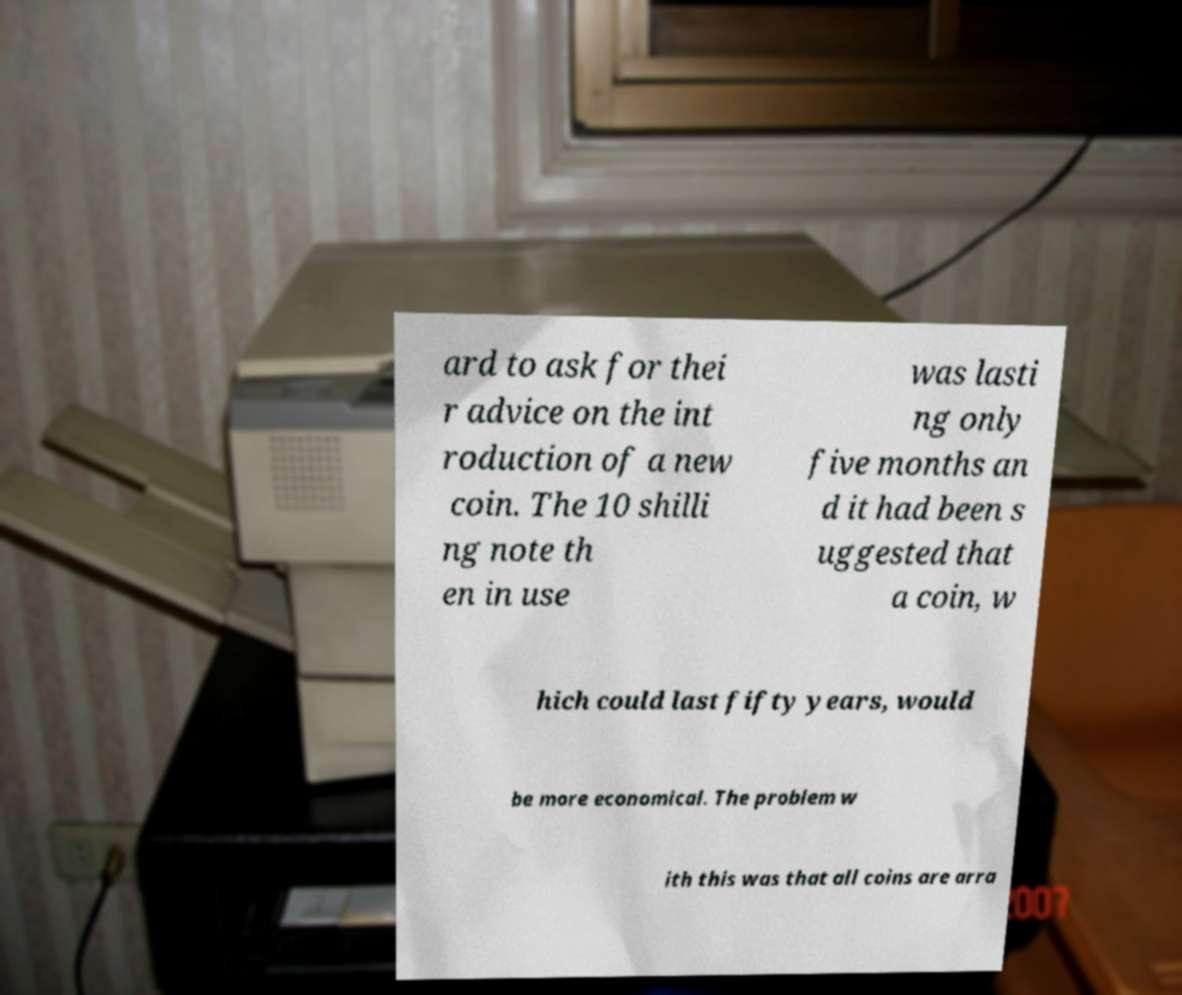There's text embedded in this image that I need extracted. Can you transcribe it verbatim? ard to ask for thei r advice on the int roduction of a new coin. The 10 shilli ng note th en in use was lasti ng only five months an d it had been s uggested that a coin, w hich could last fifty years, would be more economical. The problem w ith this was that all coins are arra 